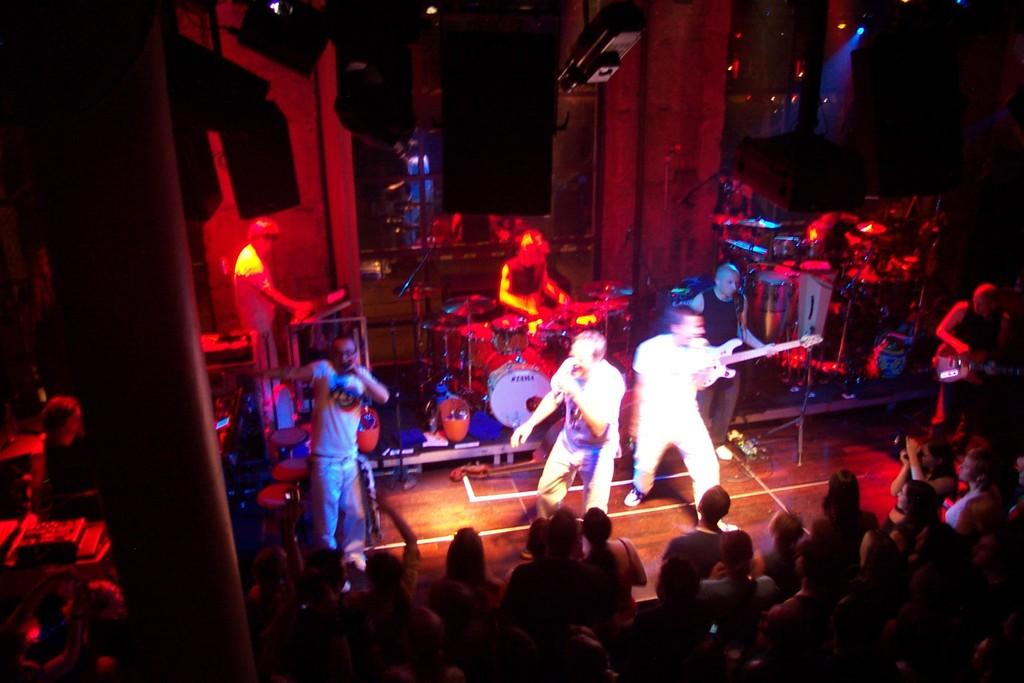How many people are in the group that is visible in the image? There is a group of people in the image, but the exact number is not specified. What are some of the people in the group doing? Some people in the group are playing musical instruments. What can be seen in the background of the image? There are lights and speakers in the background of the image. How many times do the people in the group fold their eyes during the performance? There is no indication in the image that the people in the group are folding their eyes, so it cannot be determined from the image. 